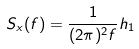<formula> <loc_0><loc_0><loc_500><loc_500>S _ { x } ( f ) = \frac { 1 } { ( 2 \pi ) ^ { 2 } f } h _ { 1 }</formula> 